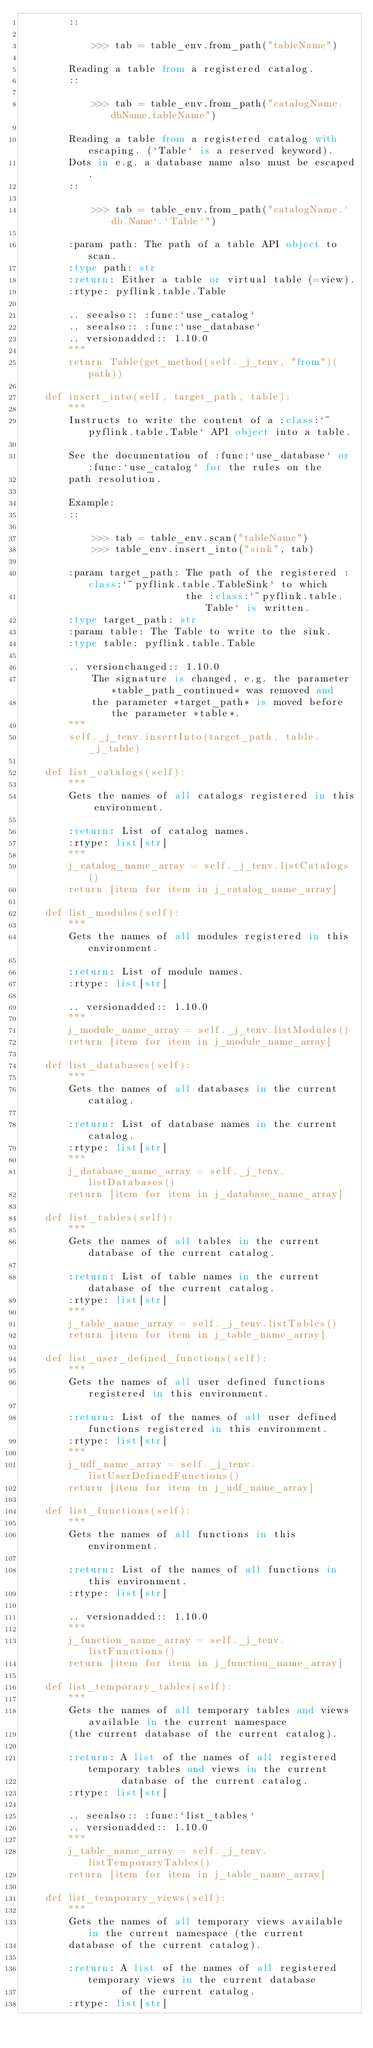<code> <loc_0><loc_0><loc_500><loc_500><_Python_>        ::

            >>> tab = table_env.from_path("tableName")

        Reading a table from a registered catalog.
        ::

            >>> tab = table_env.from_path("catalogName.dbName.tableName")

        Reading a table from a registered catalog with escaping. (`Table` is a reserved keyword).
        Dots in e.g. a database name also must be escaped.
        ::

            >>> tab = table_env.from_path("catalogName.`db.Name`.`Table`")

        :param path: The path of a table API object to scan.
        :type path: str
        :return: Either a table or virtual table (=view).
        :rtype: pyflink.table.Table

        .. seealso:: :func:`use_catalog`
        .. seealso:: :func:`use_database`
        .. versionadded:: 1.10.0
        """
        return Table(get_method(self._j_tenv, "from")(path))

    def insert_into(self, target_path, table):
        """
        Instructs to write the content of a :class:`~pyflink.table.Table` API object into a table.

        See the documentation of :func:`use_database` or :func:`use_catalog` for the rules on the
        path resolution.

        Example:
        ::

            >>> tab = table_env.scan("tableName")
            >>> table_env.insert_into("sink", tab)

        :param target_path: The path of the registered :class:`~pyflink.table.TableSink` to which
                            the :class:`~pyflink.table.Table` is written.
        :type target_path: str
        :param table: The Table to write to the sink.
        :type table: pyflink.table.Table

        .. versionchanged:: 1.10.0
            The signature is changed, e.g. the parameter *table_path_continued* was removed and
            the parameter *target_path* is moved before the parameter *table*.
        """
        self._j_tenv.insertInto(target_path, table._j_table)

    def list_catalogs(self):
        """
        Gets the names of all catalogs registered in this environment.

        :return: List of catalog names.
        :rtype: list[str]
        """
        j_catalog_name_array = self._j_tenv.listCatalogs()
        return [item for item in j_catalog_name_array]

    def list_modules(self):
        """
        Gets the names of all modules registered in this environment.

        :return: List of module names.
        :rtype: list[str]

        .. versionadded:: 1.10.0
        """
        j_module_name_array = self._j_tenv.listModules()
        return [item for item in j_module_name_array]

    def list_databases(self):
        """
        Gets the names of all databases in the current catalog.

        :return: List of database names in the current catalog.
        :rtype: list[str]
        """
        j_database_name_array = self._j_tenv.listDatabases()
        return [item for item in j_database_name_array]

    def list_tables(self):
        """
        Gets the names of all tables in the current database of the current catalog.

        :return: List of table names in the current database of the current catalog.
        :rtype: list[str]
        """
        j_table_name_array = self._j_tenv.listTables()
        return [item for item in j_table_name_array]

    def list_user_defined_functions(self):
        """
        Gets the names of all user defined functions registered in this environment.

        :return: List of the names of all user defined functions registered in this environment.
        :rtype: list[str]
        """
        j_udf_name_array = self._j_tenv.listUserDefinedFunctions()
        return [item for item in j_udf_name_array]

    def list_functions(self):
        """
        Gets the names of all functions in this environment.

        :return: List of the names of all functions in this environment.
        :rtype: list[str]

        .. versionadded:: 1.10.0
        """
        j_function_name_array = self._j_tenv.listFunctions()
        return [item for item in j_function_name_array]

    def list_temporary_tables(self):
        """
        Gets the names of all temporary tables and views available in the current namespace
        (the current database of the current catalog).

        :return: A list of the names of all registered temporary tables and views in the current
                 database of the current catalog.
        :rtype: list[str]

        .. seealso:: :func:`list_tables`
        .. versionadded:: 1.10.0
        """
        j_table_name_array = self._j_tenv.listTemporaryTables()
        return [item for item in j_table_name_array]

    def list_temporary_views(self):
        """
        Gets the names of all temporary views available in the current namespace (the current
        database of the current catalog).

        :return: A list of the names of all registered temporary views in the current database
                 of the current catalog.
        :rtype: list[str]
</code> 